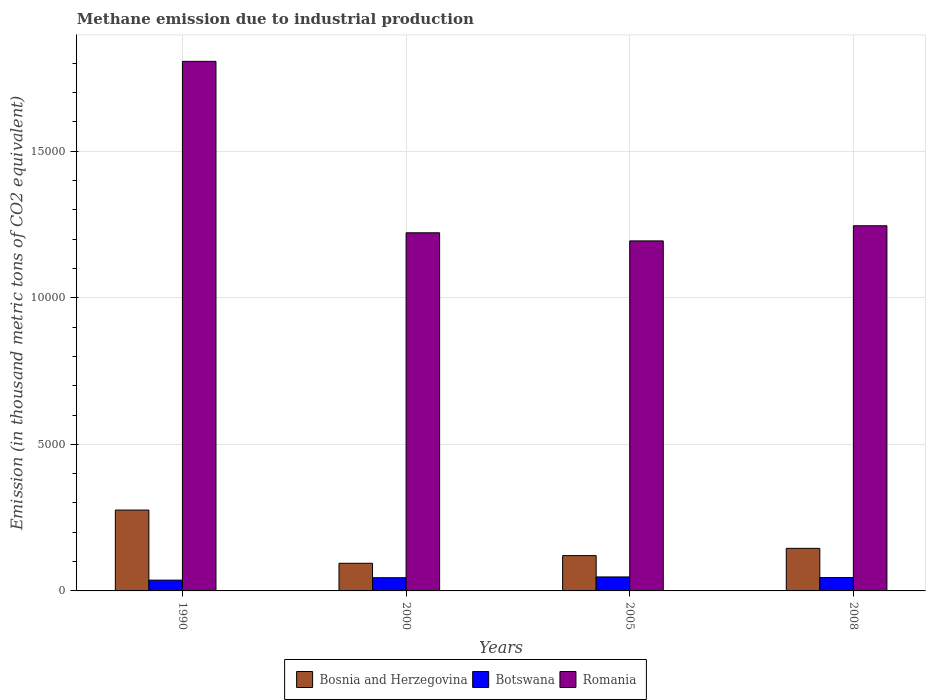How many different coloured bars are there?
Your answer should be compact. 3. Are the number of bars per tick equal to the number of legend labels?
Give a very brief answer. Yes. What is the label of the 2nd group of bars from the left?
Offer a very short reply. 2000. In how many cases, is the number of bars for a given year not equal to the number of legend labels?
Offer a very short reply. 0. What is the amount of methane emitted in Botswana in 2000?
Give a very brief answer. 451.3. Across all years, what is the maximum amount of methane emitted in Botswana?
Keep it short and to the point. 477.3. Across all years, what is the minimum amount of methane emitted in Botswana?
Provide a short and direct response. 367.9. What is the total amount of methane emitted in Romania in the graph?
Give a very brief answer. 5.47e+04. What is the difference between the amount of methane emitted in Romania in 1990 and that in 2005?
Make the answer very short. 6125.7. What is the difference between the amount of methane emitted in Bosnia and Herzegovina in 2000 and the amount of methane emitted in Romania in 2005?
Keep it short and to the point. -1.10e+04. What is the average amount of methane emitted in Botswana per year?
Your answer should be very brief. 438.02. In the year 2000, what is the difference between the amount of methane emitted in Botswana and amount of methane emitted in Bosnia and Herzegovina?
Offer a terse response. -491.9. What is the ratio of the amount of methane emitted in Bosnia and Herzegovina in 2000 to that in 2008?
Give a very brief answer. 0.65. Is the difference between the amount of methane emitted in Botswana in 1990 and 2005 greater than the difference between the amount of methane emitted in Bosnia and Herzegovina in 1990 and 2005?
Offer a very short reply. No. What is the difference between the highest and the second highest amount of methane emitted in Bosnia and Herzegovina?
Offer a very short reply. 1306.2. What is the difference between the highest and the lowest amount of methane emitted in Romania?
Give a very brief answer. 6125.7. What does the 1st bar from the left in 1990 represents?
Provide a short and direct response. Bosnia and Herzegovina. What does the 3rd bar from the right in 2008 represents?
Make the answer very short. Bosnia and Herzegovina. How many bars are there?
Ensure brevity in your answer.  12. How many years are there in the graph?
Ensure brevity in your answer.  4. What is the difference between two consecutive major ticks on the Y-axis?
Your answer should be compact. 5000. Does the graph contain any zero values?
Your answer should be very brief. No. Does the graph contain grids?
Offer a terse response. Yes. Where does the legend appear in the graph?
Your answer should be very brief. Bottom center. How many legend labels are there?
Offer a terse response. 3. What is the title of the graph?
Make the answer very short. Methane emission due to industrial production. What is the label or title of the X-axis?
Offer a terse response. Years. What is the label or title of the Y-axis?
Give a very brief answer. Emission (in thousand metric tons of CO2 equivalent). What is the Emission (in thousand metric tons of CO2 equivalent) in Bosnia and Herzegovina in 1990?
Keep it short and to the point. 2758.5. What is the Emission (in thousand metric tons of CO2 equivalent) in Botswana in 1990?
Your answer should be very brief. 367.9. What is the Emission (in thousand metric tons of CO2 equivalent) in Romania in 1990?
Make the answer very short. 1.81e+04. What is the Emission (in thousand metric tons of CO2 equivalent) of Bosnia and Herzegovina in 2000?
Keep it short and to the point. 943.2. What is the Emission (in thousand metric tons of CO2 equivalent) of Botswana in 2000?
Make the answer very short. 451.3. What is the Emission (in thousand metric tons of CO2 equivalent) of Romania in 2000?
Your answer should be very brief. 1.22e+04. What is the Emission (in thousand metric tons of CO2 equivalent) in Bosnia and Herzegovina in 2005?
Provide a short and direct response. 1204.3. What is the Emission (in thousand metric tons of CO2 equivalent) in Botswana in 2005?
Provide a short and direct response. 477.3. What is the Emission (in thousand metric tons of CO2 equivalent) in Romania in 2005?
Provide a short and direct response. 1.19e+04. What is the Emission (in thousand metric tons of CO2 equivalent) in Bosnia and Herzegovina in 2008?
Make the answer very short. 1452.3. What is the Emission (in thousand metric tons of CO2 equivalent) in Botswana in 2008?
Offer a very short reply. 455.6. What is the Emission (in thousand metric tons of CO2 equivalent) of Romania in 2008?
Ensure brevity in your answer.  1.25e+04. Across all years, what is the maximum Emission (in thousand metric tons of CO2 equivalent) in Bosnia and Herzegovina?
Your answer should be compact. 2758.5. Across all years, what is the maximum Emission (in thousand metric tons of CO2 equivalent) in Botswana?
Offer a terse response. 477.3. Across all years, what is the maximum Emission (in thousand metric tons of CO2 equivalent) of Romania?
Provide a short and direct response. 1.81e+04. Across all years, what is the minimum Emission (in thousand metric tons of CO2 equivalent) of Bosnia and Herzegovina?
Keep it short and to the point. 943.2. Across all years, what is the minimum Emission (in thousand metric tons of CO2 equivalent) in Botswana?
Your answer should be compact. 367.9. Across all years, what is the minimum Emission (in thousand metric tons of CO2 equivalent) of Romania?
Keep it short and to the point. 1.19e+04. What is the total Emission (in thousand metric tons of CO2 equivalent) in Bosnia and Herzegovina in the graph?
Give a very brief answer. 6358.3. What is the total Emission (in thousand metric tons of CO2 equivalent) of Botswana in the graph?
Provide a short and direct response. 1752.1. What is the total Emission (in thousand metric tons of CO2 equivalent) of Romania in the graph?
Your answer should be compact. 5.47e+04. What is the difference between the Emission (in thousand metric tons of CO2 equivalent) in Bosnia and Herzegovina in 1990 and that in 2000?
Give a very brief answer. 1815.3. What is the difference between the Emission (in thousand metric tons of CO2 equivalent) of Botswana in 1990 and that in 2000?
Your answer should be compact. -83.4. What is the difference between the Emission (in thousand metric tons of CO2 equivalent) of Romania in 1990 and that in 2000?
Your answer should be compact. 5849.1. What is the difference between the Emission (in thousand metric tons of CO2 equivalent) in Bosnia and Herzegovina in 1990 and that in 2005?
Ensure brevity in your answer.  1554.2. What is the difference between the Emission (in thousand metric tons of CO2 equivalent) in Botswana in 1990 and that in 2005?
Give a very brief answer. -109.4. What is the difference between the Emission (in thousand metric tons of CO2 equivalent) of Romania in 1990 and that in 2005?
Your answer should be compact. 6125.7. What is the difference between the Emission (in thousand metric tons of CO2 equivalent) in Bosnia and Herzegovina in 1990 and that in 2008?
Keep it short and to the point. 1306.2. What is the difference between the Emission (in thousand metric tons of CO2 equivalent) in Botswana in 1990 and that in 2008?
Keep it short and to the point. -87.7. What is the difference between the Emission (in thousand metric tons of CO2 equivalent) in Romania in 1990 and that in 2008?
Provide a short and direct response. 5609.2. What is the difference between the Emission (in thousand metric tons of CO2 equivalent) of Bosnia and Herzegovina in 2000 and that in 2005?
Your response must be concise. -261.1. What is the difference between the Emission (in thousand metric tons of CO2 equivalent) of Romania in 2000 and that in 2005?
Make the answer very short. 276.6. What is the difference between the Emission (in thousand metric tons of CO2 equivalent) of Bosnia and Herzegovina in 2000 and that in 2008?
Offer a very short reply. -509.1. What is the difference between the Emission (in thousand metric tons of CO2 equivalent) in Botswana in 2000 and that in 2008?
Offer a terse response. -4.3. What is the difference between the Emission (in thousand metric tons of CO2 equivalent) in Romania in 2000 and that in 2008?
Your response must be concise. -239.9. What is the difference between the Emission (in thousand metric tons of CO2 equivalent) in Bosnia and Herzegovina in 2005 and that in 2008?
Keep it short and to the point. -248. What is the difference between the Emission (in thousand metric tons of CO2 equivalent) of Botswana in 2005 and that in 2008?
Give a very brief answer. 21.7. What is the difference between the Emission (in thousand metric tons of CO2 equivalent) in Romania in 2005 and that in 2008?
Offer a very short reply. -516.5. What is the difference between the Emission (in thousand metric tons of CO2 equivalent) in Bosnia and Herzegovina in 1990 and the Emission (in thousand metric tons of CO2 equivalent) in Botswana in 2000?
Ensure brevity in your answer.  2307.2. What is the difference between the Emission (in thousand metric tons of CO2 equivalent) in Bosnia and Herzegovina in 1990 and the Emission (in thousand metric tons of CO2 equivalent) in Romania in 2000?
Offer a very short reply. -9460.5. What is the difference between the Emission (in thousand metric tons of CO2 equivalent) of Botswana in 1990 and the Emission (in thousand metric tons of CO2 equivalent) of Romania in 2000?
Offer a terse response. -1.19e+04. What is the difference between the Emission (in thousand metric tons of CO2 equivalent) of Bosnia and Herzegovina in 1990 and the Emission (in thousand metric tons of CO2 equivalent) of Botswana in 2005?
Your answer should be compact. 2281.2. What is the difference between the Emission (in thousand metric tons of CO2 equivalent) of Bosnia and Herzegovina in 1990 and the Emission (in thousand metric tons of CO2 equivalent) of Romania in 2005?
Provide a short and direct response. -9183.9. What is the difference between the Emission (in thousand metric tons of CO2 equivalent) in Botswana in 1990 and the Emission (in thousand metric tons of CO2 equivalent) in Romania in 2005?
Your answer should be compact. -1.16e+04. What is the difference between the Emission (in thousand metric tons of CO2 equivalent) in Bosnia and Herzegovina in 1990 and the Emission (in thousand metric tons of CO2 equivalent) in Botswana in 2008?
Keep it short and to the point. 2302.9. What is the difference between the Emission (in thousand metric tons of CO2 equivalent) in Bosnia and Herzegovina in 1990 and the Emission (in thousand metric tons of CO2 equivalent) in Romania in 2008?
Ensure brevity in your answer.  -9700.4. What is the difference between the Emission (in thousand metric tons of CO2 equivalent) in Botswana in 1990 and the Emission (in thousand metric tons of CO2 equivalent) in Romania in 2008?
Provide a succinct answer. -1.21e+04. What is the difference between the Emission (in thousand metric tons of CO2 equivalent) of Bosnia and Herzegovina in 2000 and the Emission (in thousand metric tons of CO2 equivalent) of Botswana in 2005?
Your answer should be very brief. 465.9. What is the difference between the Emission (in thousand metric tons of CO2 equivalent) in Bosnia and Herzegovina in 2000 and the Emission (in thousand metric tons of CO2 equivalent) in Romania in 2005?
Offer a very short reply. -1.10e+04. What is the difference between the Emission (in thousand metric tons of CO2 equivalent) of Botswana in 2000 and the Emission (in thousand metric tons of CO2 equivalent) of Romania in 2005?
Your answer should be compact. -1.15e+04. What is the difference between the Emission (in thousand metric tons of CO2 equivalent) of Bosnia and Herzegovina in 2000 and the Emission (in thousand metric tons of CO2 equivalent) of Botswana in 2008?
Your answer should be very brief. 487.6. What is the difference between the Emission (in thousand metric tons of CO2 equivalent) in Bosnia and Herzegovina in 2000 and the Emission (in thousand metric tons of CO2 equivalent) in Romania in 2008?
Ensure brevity in your answer.  -1.15e+04. What is the difference between the Emission (in thousand metric tons of CO2 equivalent) in Botswana in 2000 and the Emission (in thousand metric tons of CO2 equivalent) in Romania in 2008?
Provide a short and direct response. -1.20e+04. What is the difference between the Emission (in thousand metric tons of CO2 equivalent) in Bosnia and Herzegovina in 2005 and the Emission (in thousand metric tons of CO2 equivalent) in Botswana in 2008?
Give a very brief answer. 748.7. What is the difference between the Emission (in thousand metric tons of CO2 equivalent) in Bosnia and Herzegovina in 2005 and the Emission (in thousand metric tons of CO2 equivalent) in Romania in 2008?
Provide a succinct answer. -1.13e+04. What is the difference between the Emission (in thousand metric tons of CO2 equivalent) in Botswana in 2005 and the Emission (in thousand metric tons of CO2 equivalent) in Romania in 2008?
Give a very brief answer. -1.20e+04. What is the average Emission (in thousand metric tons of CO2 equivalent) in Bosnia and Herzegovina per year?
Offer a very short reply. 1589.58. What is the average Emission (in thousand metric tons of CO2 equivalent) of Botswana per year?
Your answer should be compact. 438.02. What is the average Emission (in thousand metric tons of CO2 equivalent) of Romania per year?
Provide a succinct answer. 1.37e+04. In the year 1990, what is the difference between the Emission (in thousand metric tons of CO2 equivalent) in Bosnia and Herzegovina and Emission (in thousand metric tons of CO2 equivalent) in Botswana?
Your answer should be compact. 2390.6. In the year 1990, what is the difference between the Emission (in thousand metric tons of CO2 equivalent) of Bosnia and Herzegovina and Emission (in thousand metric tons of CO2 equivalent) of Romania?
Your response must be concise. -1.53e+04. In the year 1990, what is the difference between the Emission (in thousand metric tons of CO2 equivalent) in Botswana and Emission (in thousand metric tons of CO2 equivalent) in Romania?
Your answer should be compact. -1.77e+04. In the year 2000, what is the difference between the Emission (in thousand metric tons of CO2 equivalent) of Bosnia and Herzegovina and Emission (in thousand metric tons of CO2 equivalent) of Botswana?
Provide a succinct answer. 491.9. In the year 2000, what is the difference between the Emission (in thousand metric tons of CO2 equivalent) in Bosnia and Herzegovina and Emission (in thousand metric tons of CO2 equivalent) in Romania?
Ensure brevity in your answer.  -1.13e+04. In the year 2000, what is the difference between the Emission (in thousand metric tons of CO2 equivalent) in Botswana and Emission (in thousand metric tons of CO2 equivalent) in Romania?
Provide a succinct answer. -1.18e+04. In the year 2005, what is the difference between the Emission (in thousand metric tons of CO2 equivalent) in Bosnia and Herzegovina and Emission (in thousand metric tons of CO2 equivalent) in Botswana?
Ensure brevity in your answer.  727. In the year 2005, what is the difference between the Emission (in thousand metric tons of CO2 equivalent) of Bosnia and Herzegovina and Emission (in thousand metric tons of CO2 equivalent) of Romania?
Ensure brevity in your answer.  -1.07e+04. In the year 2005, what is the difference between the Emission (in thousand metric tons of CO2 equivalent) in Botswana and Emission (in thousand metric tons of CO2 equivalent) in Romania?
Offer a terse response. -1.15e+04. In the year 2008, what is the difference between the Emission (in thousand metric tons of CO2 equivalent) in Bosnia and Herzegovina and Emission (in thousand metric tons of CO2 equivalent) in Botswana?
Provide a succinct answer. 996.7. In the year 2008, what is the difference between the Emission (in thousand metric tons of CO2 equivalent) of Bosnia and Herzegovina and Emission (in thousand metric tons of CO2 equivalent) of Romania?
Offer a very short reply. -1.10e+04. In the year 2008, what is the difference between the Emission (in thousand metric tons of CO2 equivalent) in Botswana and Emission (in thousand metric tons of CO2 equivalent) in Romania?
Offer a terse response. -1.20e+04. What is the ratio of the Emission (in thousand metric tons of CO2 equivalent) in Bosnia and Herzegovina in 1990 to that in 2000?
Offer a very short reply. 2.92. What is the ratio of the Emission (in thousand metric tons of CO2 equivalent) in Botswana in 1990 to that in 2000?
Give a very brief answer. 0.82. What is the ratio of the Emission (in thousand metric tons of CO2 equivalent) in Romania in 1990 to that in 2000?
Your answer should be very brief. 1.48. What is the ratio of the Emission (in thousand metric tons of CO2 equivalent) in Bosnia and Herzegovina in 1990 to that in 2005?
Offer a very short reply. 2.29. What is the ratio of the Emission (in thousand metric tons of CO2 equivalent) in Botswana in 1990 to that in 2005?
Give a very brief answer. 0.77. What is the ratio of the Emission (in thousand metric tons of CO2 equivalent) in Romania in 1990 to that in 2005?
Ensure brevity in your answer.  1.51. What is the ratio of the Emission (in thousand metric tons of CO2 equivalent) in Bosnia and Herzegovina in 1990 to that in 2008?
Provide a succinct answer. 1.9. What is the ratio of the Emission (in thousand metric tons of CO2 equivalent) in Botswana in 1990 to that in 2008?
Provide a short and direct response. 0.81. What is the ratio of the Emission (in thousand metric tons of CO2 equivalent) of Romania in 1990 to that in 2008?
Your response must be concise. 1.45. What is the ratio of the Emission (in thousand metric tons of CO2 equivalent) in Bosnia and Herzegovina in 2000 to that in 2005?
Provide a succinct answer. 0.78. What is the ratio of the Emission (in thousand metric tons of CO2 equivalent) in Botswana in 2000 to that in 2005?
Offer a terse response. 0.95. What is the ratio of the Emission (in thousand metric tons of CO2 equivalent) in Romania in 2000 to that in 2005?
Keep it short and to the point. 1.02. What is the ratio of the Emission (in thousand metric tons of CO2 equivalent) of Bosnia and Herzegovina in 2000 to that in 2008?
Your answer should be compact. 0.65. What is the ratio of the Emission (in thousand metric tons of CO2 equivalent) of Botswana in 2000 to that in 2008?
Your answer should be compact. 0.99. What is the ratio of the Emission (in thousand metric tons of CO2 equivalent) in Romania in 2000 to that in 2008?
Provide a succinct answer. 0.98. What is the ratio of the Emission (in thousand metric tons of CO2 equivalent) in Bosnia and Herzegovina in 2005 to that in 2008?
Give a very brief answer. 0.83. What is the ratio of the Emission (in thousand metric tons of CO2 equivalent) of Botswana in 2005 to that in 2008?
Keep it short and to the point. 1.05. What is the ratio of the Emission (in thousand metric tons of CO2 equivalent) in Romania in 2005 to that in 2008?
Provide a short and direct response. 0.96. What is the difference between the highest and the second highest Emission (in thousand metric tons of CO2 equivalent) in Bosnia and Herzegovina?
Provide a short and direct response. 1306.2. What is the difference between the highest and the second highest Emission (in thousand metric tons of CO2 equivalent) of Botswana?
Provide a short and direct response. 21.7. What is the difference between the highest and the second highest Emission (in thousand metric tons of CO2 equivalent) of Romania?
Keep it short and to the point. 5609.2. What is the difference between the highest and the lowest Emission (in thousand metric tons of CO2 equivalent) in Bosnia and Herzegovina?
Keep it short and to the point. 1815.3. What is the difference between the highest and the lowest Emission (in thousand metric tons of CO2 equivalent) in Botswana?
Your answer should be compact. 109.4. What is the difference between the highest and the lowest Emission (in thousand metric tons of CO2 equivalent) of Romania?
Provide a succinct answer. 6125.7. 